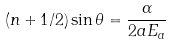Convert formula to latex. <formula><loc_0><loc_0><loc_500><loc_500>( n + 1 / 2 ) \sin \theta = \frac { \alpha } { 2 a E _ { a } }</formula> 